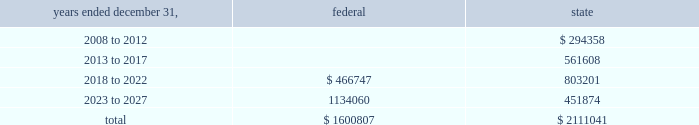American tower corporation and subsidiaries notes to consolidated financial statements 2014 ( continued ) for the years ended december 31 , 2007 and 2006 , the company increased net deferred tax assets by $ 1.5 million and $ 7.2 million , respectively with a corresponding reduction of goodwill associated with the utilization of net operating and capital losses acquired in connection with the spectrasite , inc .
Merger .
These deferred tax assets were assigned a full valuation allowance as part of the final spectrasite purchase price allocation in june 2006 , as evidence available at the time did not support that losses were more likely than not to be realized .
The valuation allowance decreased from $ 308.2 million as of december 31 , 2006 to $ 88.2 million as of december 31 , 2007 .
The decrease was primarily due to a $ 149.6 million reclassification to the fin 48 opening balance ( related to federal and state net operating losses acquired in connection with the spectrasite , inc .
Merger ) and $ 45.2 million of allowance reductions during the year ended december 31 , 2007 related to state net operating losses , capital loss expirations of $ 6.5 million and other items .
The company 2019s deferred tax assets as of december 31 , 2007 and 2006 in the table above do not include $ 74.9 million and $ 31.0 million , respectively , of excess tax benefits from the exercises of employee stock options that are a component of net operating losses due to the adoption of sfas no .
123r .
Total stockholders 2019 equity will be increased by $ 74.9 million if and when any such excess tax benefits are ultimately realized .
Basis step-up from corporate restructuring represents the tax effects of increasing the basis for tax purposes of certain of the company 2019s assets in conjunction with its spin-off from american radio systems corporation , its former parent company .
At december 31 , 2007 , the company had net federal and state operating loss carryforwards available to reduce future federal and state taxable income of approximately $ 1.6 billion and $ 2.1 billion , respectively .
If not utilized , the company 2019s net operating loss carryforwards expire as follows ( in thousands ) : .
As described in note 1 , the company adopted the provisions of fin 48 on january 1 , 2007 .
As of january 1 , 2007 , the total amount of unrecognized tax benefits was $ 183.9 million of which $ 34.3 million would affect the effective tax rate , if recognized .
As of december 31 , 2007 , the total amount of unrecognized tax benefits was $ 59.2 million , $ 23.0 million of which would affect the effective tax rate , if recognized .
The company expects the unrecognized tax benefits to change over the next 12 months if certain tax matters ultimately settle with the applicable taxing jurisdiction during this timeframe .
However , based on the status of these items and the amount of uncertainty associated with the outcome and timing of audit settlements , the .
What is the change in balance of unrecognized tax benefits during 2007? 
Computations: (59.2 - 183.9)
Answer: -124.7. 